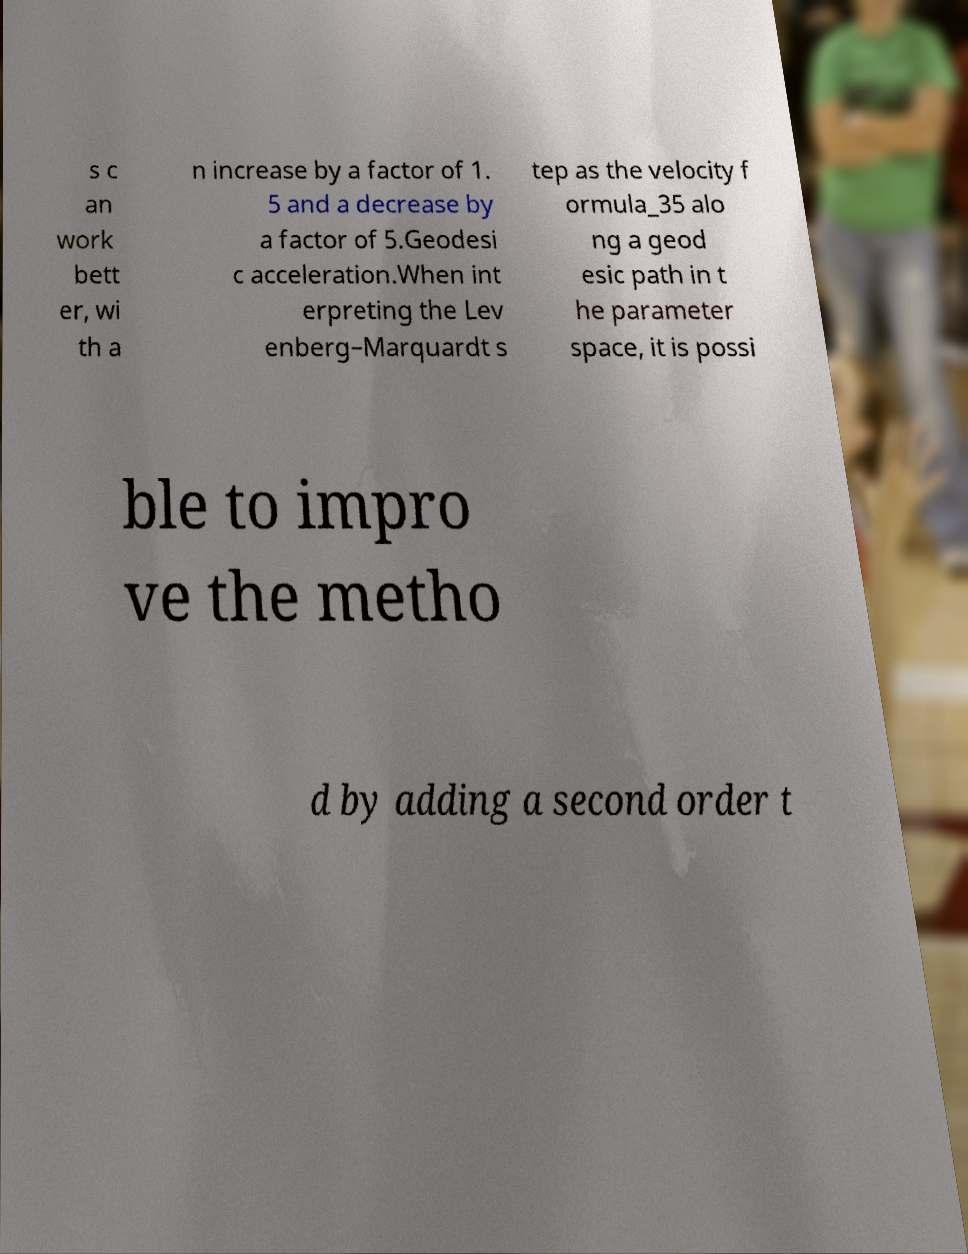Can you read and provide the text displayed in the image?This photo seems to have some interesting text. Can you extract and type it out for me? s c an work bett er, wi th a n increase by a factor of 1. 5 and a decrease by a factor of 5.Geodesi c acceleration.When int erpreting the Lev enberg–Marquardt s tep as the velocity f ormula_35 alo ng a geod esic path in t he parameter space, it is possi ble to impro ve the metho d by adding a second order t 